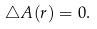<formula> <loc_0><loc_0><loc_500><loc_500>\triangle A ( r ) = 0 .</formula> 